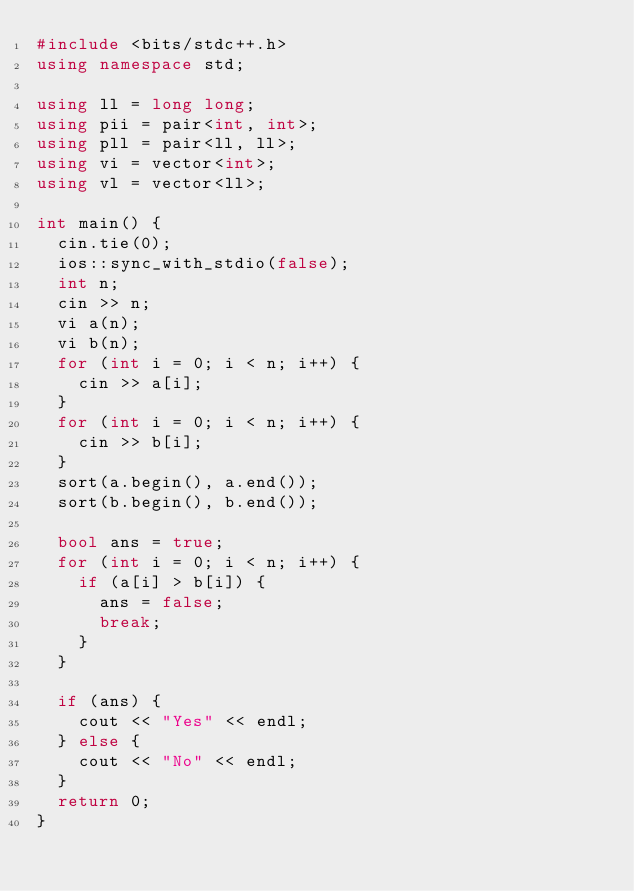Convert code to text. <code><loc_0><loc_0><loc_500><loc_500><_C++_>#include <bits/stdc++.h>
using namespace std;

using ll = long long;
using pii = pair<int, int>;
using pll = pair<ll, ll>;
using vi = vector<int>;
using vl = vector<ll>;

int main() {
  cin.tie(0);
  ios::sync_with_stdio(false);
  int n;
  cin >> n;
  vi a(n);
  vi b(n);
  for (int i = 0; i < n; i++) {
    cin >> a[i];
  }
  for (int i = 0; i < n; i++) {
    cin >> b[i];
  }
  sort(a.begin(), a.end());
  sort(b.begin(), b.end());

  bool ans = true;
  for (int i = 0; i < n; i++) {
    if (a[i] > b[i]) {
      ans = false;
      break;
    }
  }

  if (ans) {
    cout << "Yes" << endl;
  } else {
    cout << "No" << endl;
  }
  return 0;
}
</code> 